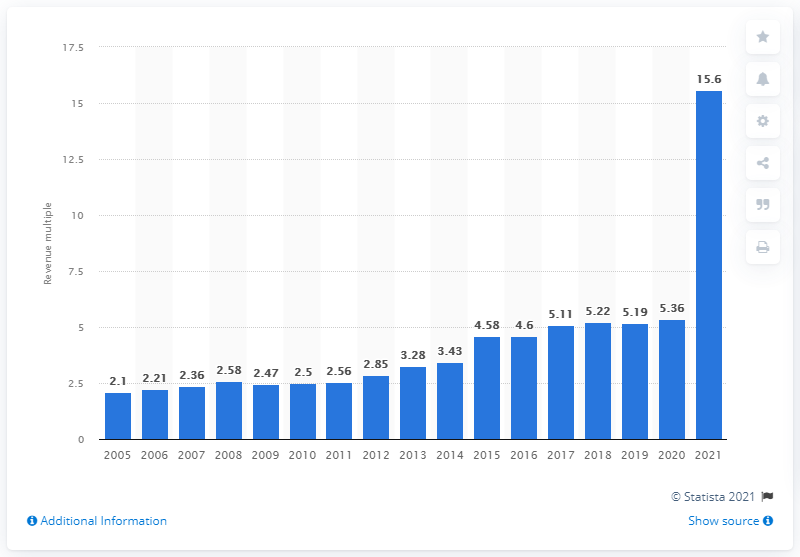Indicate a few pertinent items in this graphic. In 2021, the average revenue multiple for MLB franchises was 15.6. 